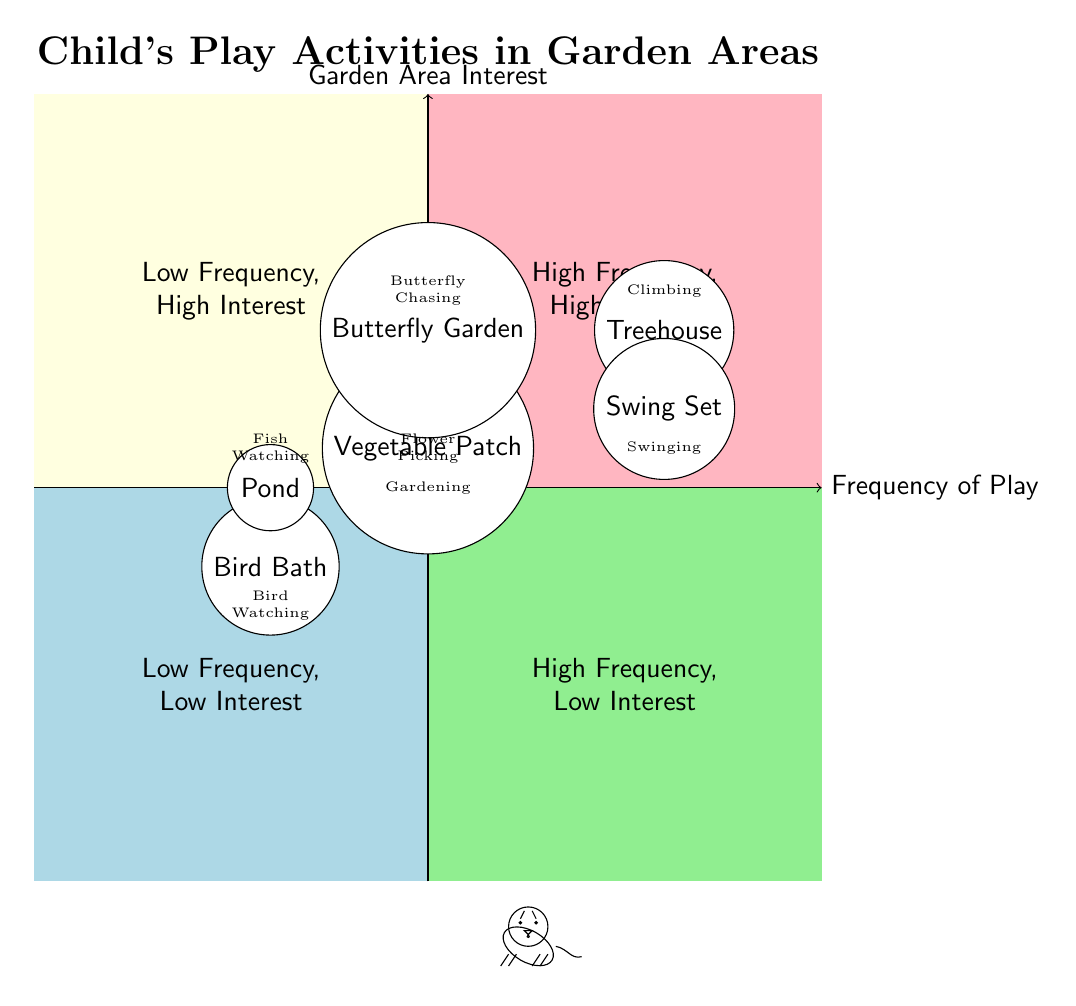What activity is associated with the Treehouse? The Treehouse is positioned in the high frequency, high interest quadrant, where it is labeled with the activity "Climbing."
Answer: Climbing How many areas have a high frequency of play? In the diagram, there are two areas (Treehouse and Swing Set) that fall into the high frequency, high interest quadrant, indicating that they are associated with high frequency of play.
Answer: 2 Which garden area is linked to the activity "Fish Watching"? The Pond is located in the low frequency, low interest quadrant, which shows that it is connected to the activity "Fish Watching."
Answer: Pond What is the frequency of play for the Vegetable Patch? The Vegetable Patch is in the medium frequency, high interest region, indicating that its frequency of play is medium.
Answer: Medium Which two areas have high frequency but low interest? In the diagram, no areas are labeled in the high frequency, low interest quadrant, which signifies that there are no areas fitting that criteria.
Answer: None What activity is linked with the Bird Bath? The Bird Bath is categorized in the low frequency, low interest quadrant and is specifically associated with the activity "Bird Watching."
Answer: Bird Watching Which activity is associated with the Swing Set? The Swing Set is placed in the high frequency, high interest area, indicating that it is linked with the activity "Swinging."
Answer: Swinging Is there an area where the child engages in activities at low frequency? Yes, the areas such as Bird Bath and Pond demonstrate that they are linked to activities performed at a low frequency, qualifying as low frequency areas.
Answer: Yes 